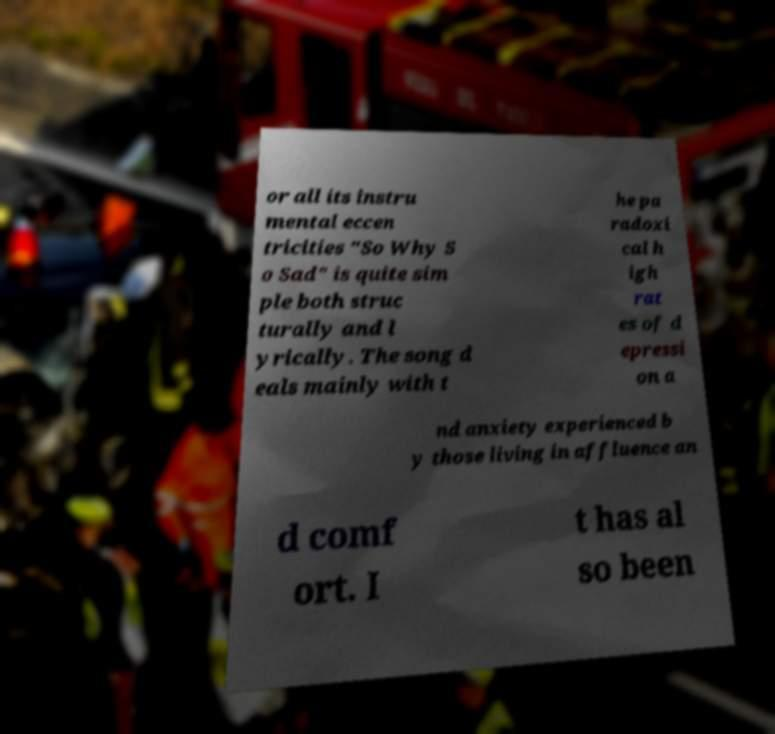Could you assist in decoding the text presented in this image and type it out clearly? or all its instru mental eccen tricities "So Why S o Sad" is quite sim ple both struc turally and l yrically. The song d eals mainly with t he pa radoxi cal h igh rat es of d epressi on a nd anxiety experienced b y those living in affluence an d comf ort. I t has al so been 